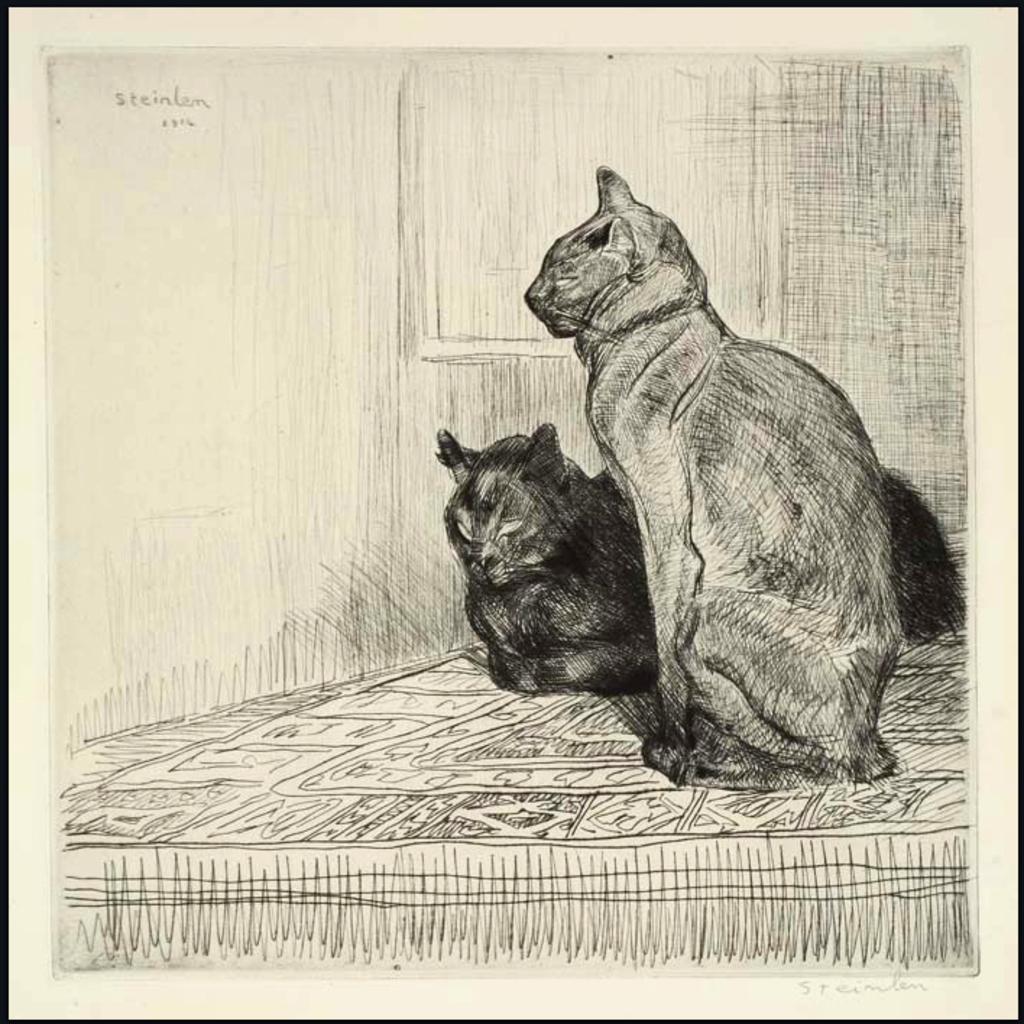Could you give a brief overview of what you see in this image? In this picture we can see a drawing, here we can see cats on a platform and we can see a wall in the background, in the top left we can see some text on it. 